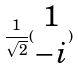<formula> <loc_0><loc_0><loc_500><loc_500>\frac { 1 } { \sqrt { 2 } } ( \begin{matrix} 1 \\ - i \end{matrix} )</formula> 